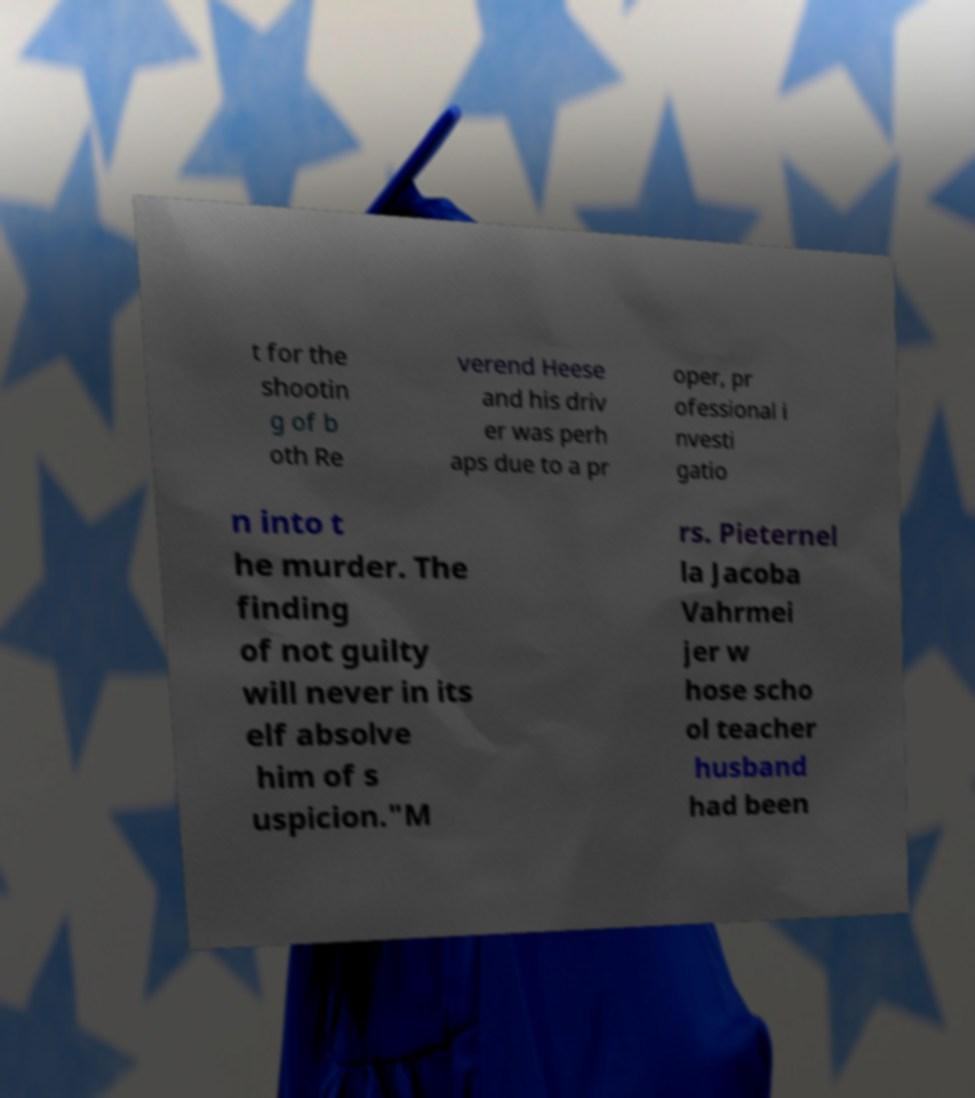Could you extract and type out the text from this image? t for the shootin g of b oth Re verend Heese and his driv er was perh aps due to a pr oper, pr ofessional i nvesti gatio n into t he murder. The finding of not guilty will never in its elf absolve him of s uspicion."M rs. Pieternel la Jacoba Vahrmei jer w hose scho ol teacher husband had been 